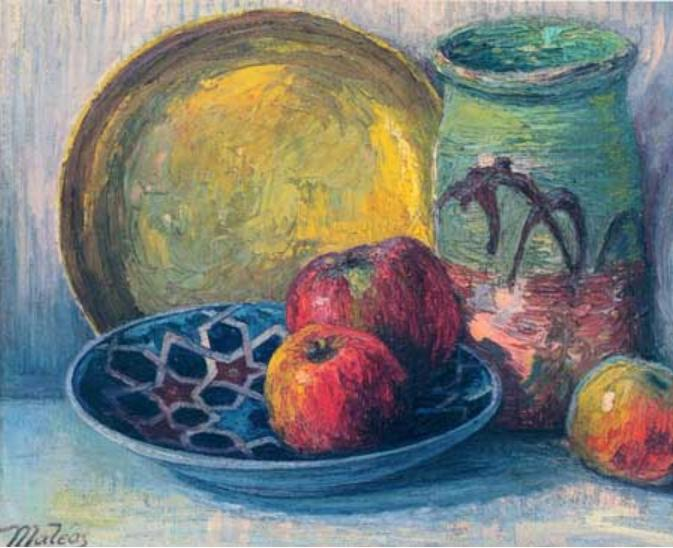What could the objects in the image symbolize in a philosophical interpretation? In a philosophical interpretation, the objects in this painting could symbolize various aspects of human experience and thought.

The yellow plate, with its warm and inviting hue, could represent the nurturing and sustaining aspects of life—such as family, home, and the comfort of routine. Its subtle, almost glowing presence reminds us of the essential yet often taken-for-granted support systems in our lives.

The blue bowl, with its geometric patterns and deep color, might symbolize the mind’s complexity and the search for deeper meaning. Blue often represents intellect and contemplation, suggesting that the bowl holds within it the mysteries of thought and introspection.

The green vase, adorned with organic, vine-like patterns, stands for growth, connection, and the passage of time. Green is the color of life and renewal, and the vase could be seen as a metaphor for our connections to nature and the continuous cycle of growth and decay.

The red apples, vibrant and tempting, could symbolize passion, desire, and vitality. They are the most eye-catching elements, representing the heart’s emotions and the drive that pushes us forward in life.

Together, these objects reflect a balanced and multifaceted view of life, intertwining the physical, mental, and emotional experiences that make up our existence. 